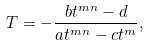<formula> <loc_0><loc_0><loc_500><loc_500>T = - \frac { b t ^ { m n } - d } { a t ^ { m n } - c t ^ { m } } ,</formula> 